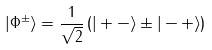Convert formula to latex. <formula><loc_0><loc_0><loc_500><loc_500>| \Phi ^ { \pm } \rangle = \frac { 1 } { \sqrt { 2 } } \left ( | + - \rangle \pm | - + \rangle \right )</formula> 